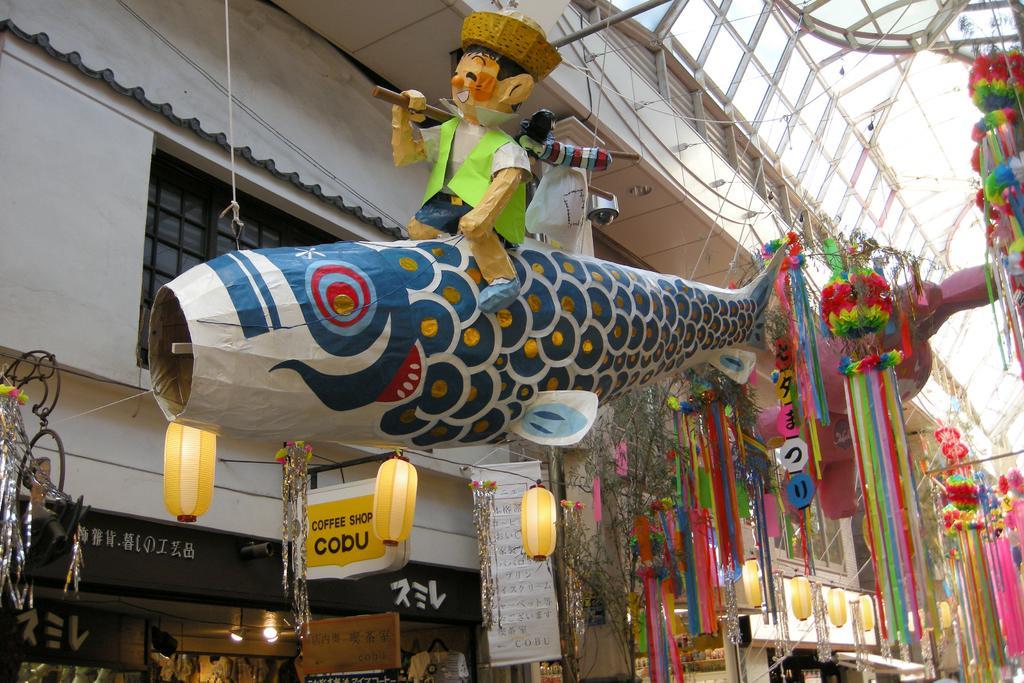Please provide a concise description of this image. This is a picture of the outside of the building, in this picture in the center there is one toy. On the right side there are some ribbons, flowers, and lights and some decorations. And in the background there are some buildings and stores, on the right side there are some lights and some boards. And on the top of the image there are some rods. 